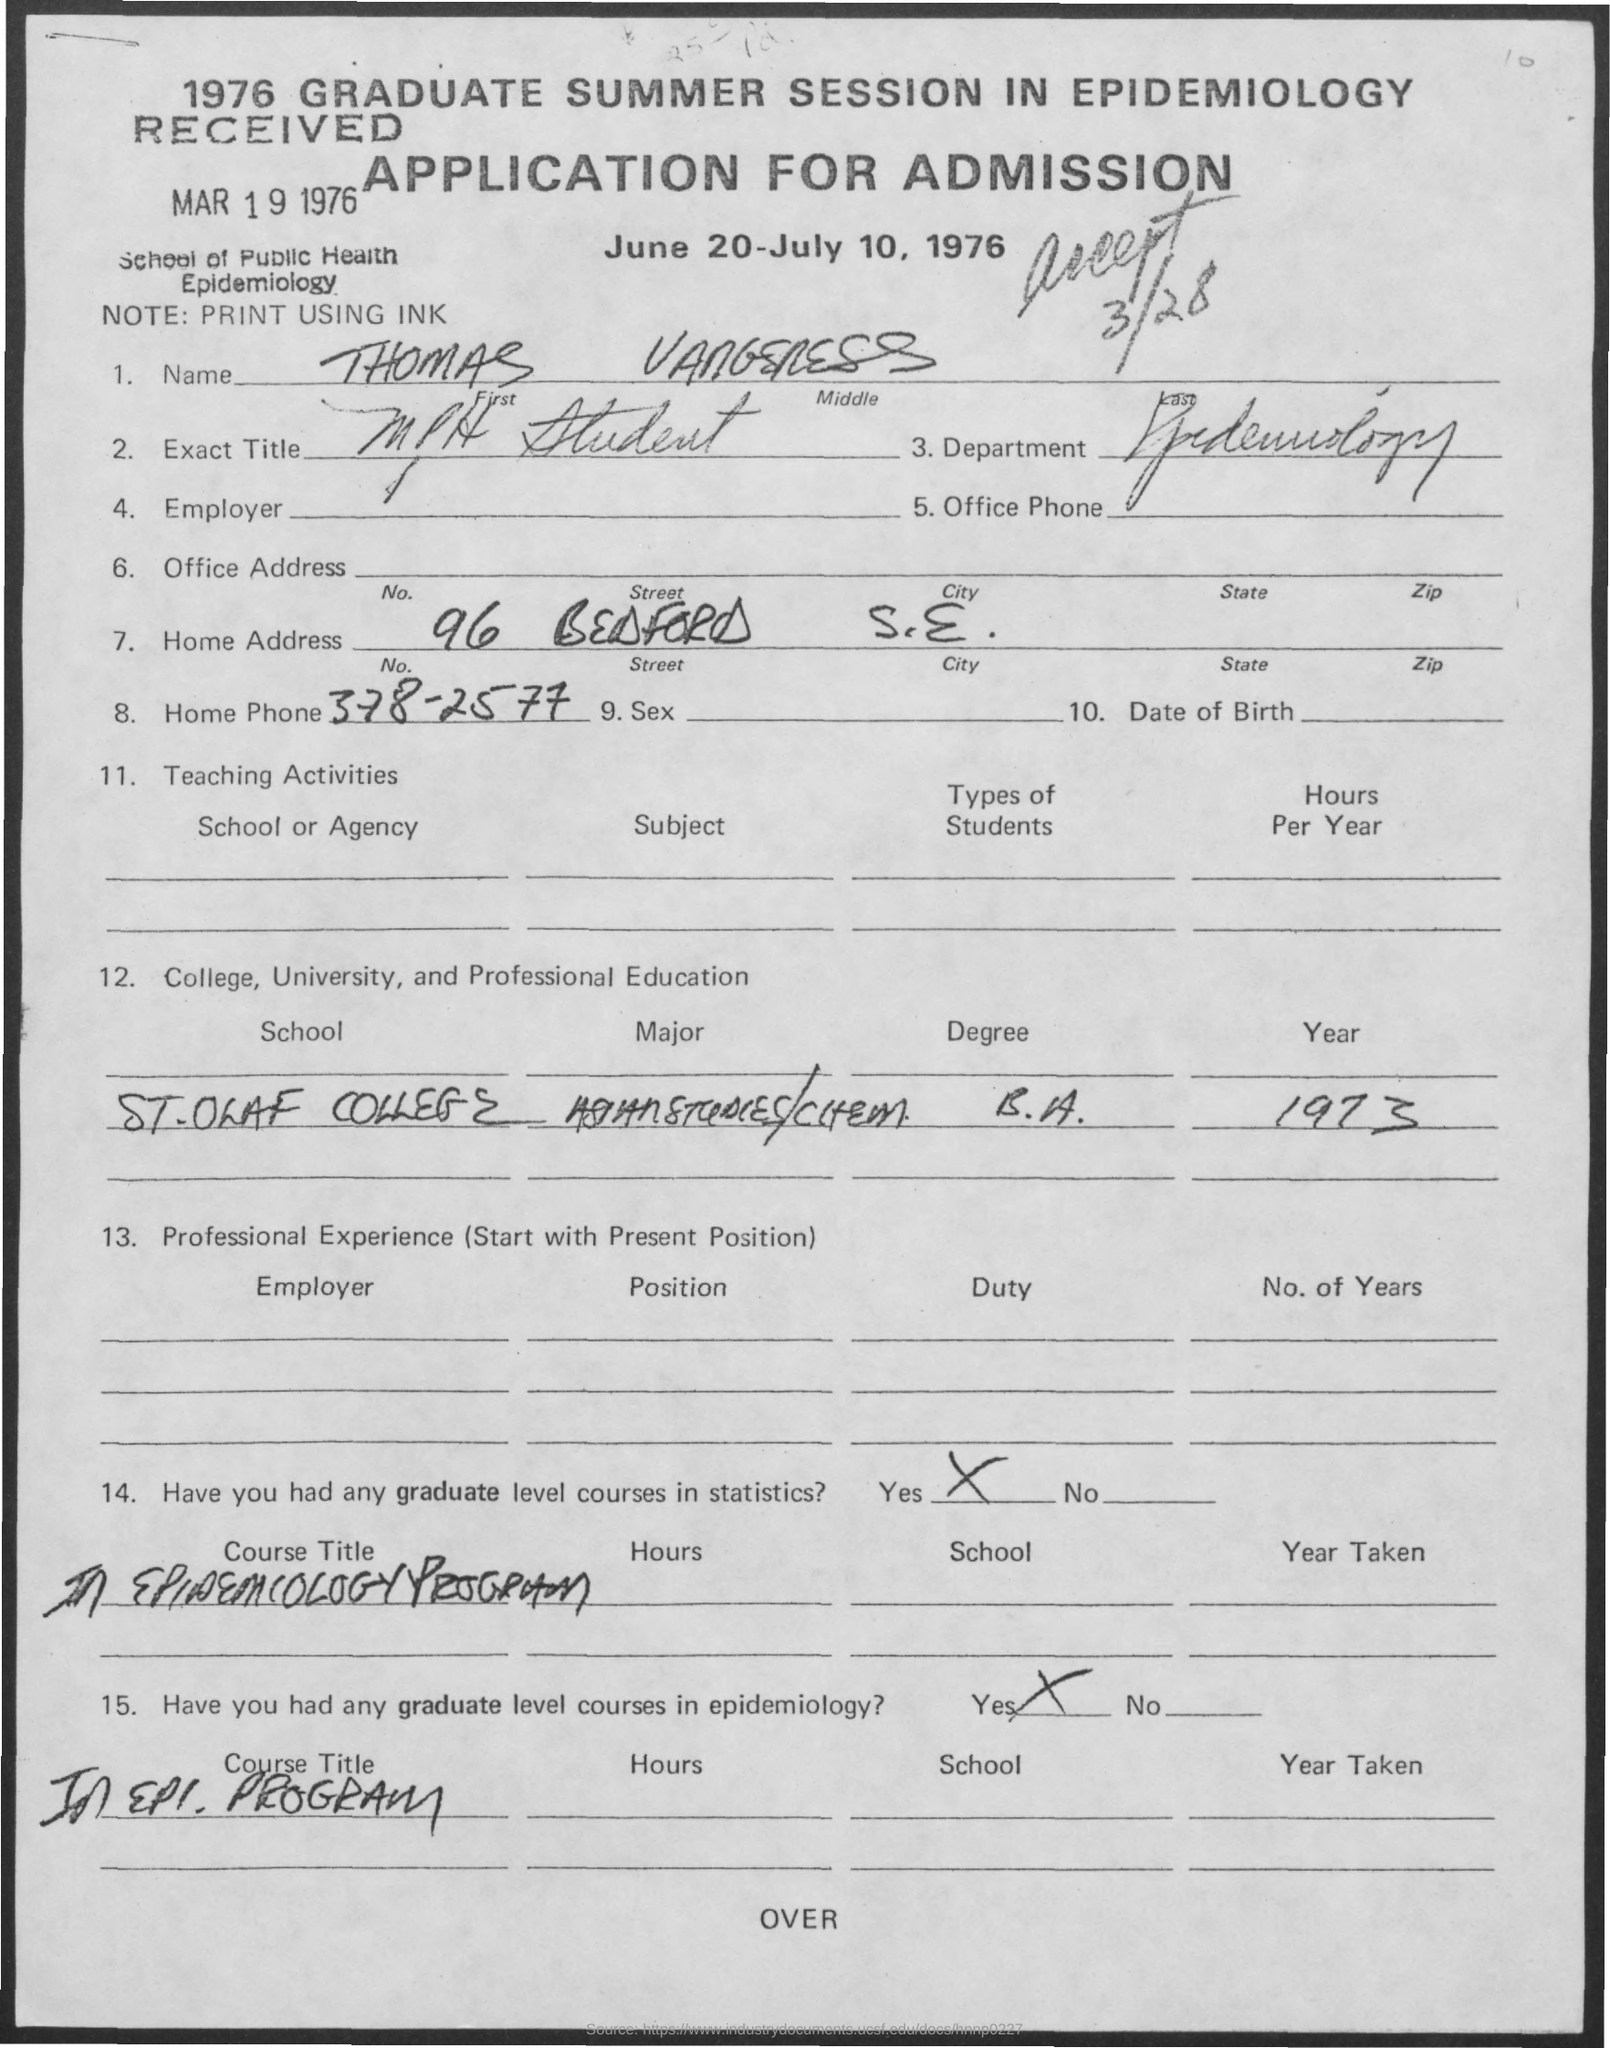What is the First Name?
Provide a short and direct response. Thomas. What is the Department?
Keep it short and to the point. Epidemiology. What is the Home Phone?
Provide a succinct answer. 378-2577. Which Year was he in St. Olaf College?
Make the answer very short. 1973. 